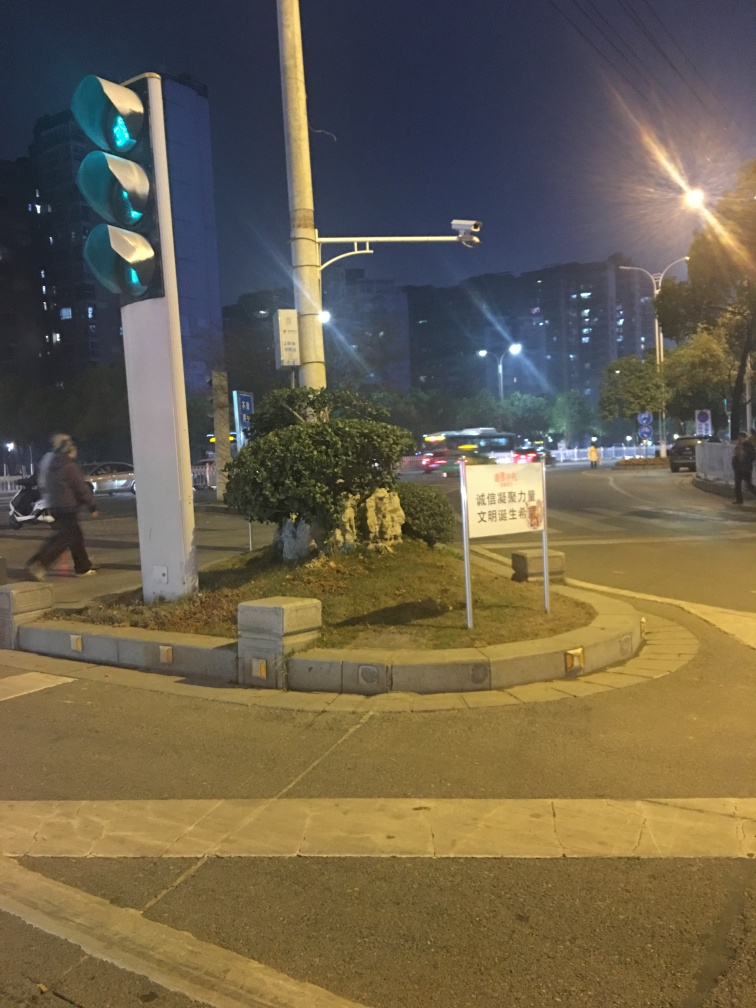What kind of vehicles are present in this image, and what can that tell us about the traffic? The image displays a variety of vehicles, including cars and what might be a bus, indicating mixed traffic. The presence of multiple lanes and a traffic light suggests an organized road structure, potentially in an urban setting. Looking at the traffic light, what is the current signal and what does it tell drivers and pedestrians? The traffic light displays a green light, indicating that vehicles in this lane have the right-of-way to proceed. Pedestrians should be cautious and obey any corresponding pedestrian signals which are not visible in the image. 